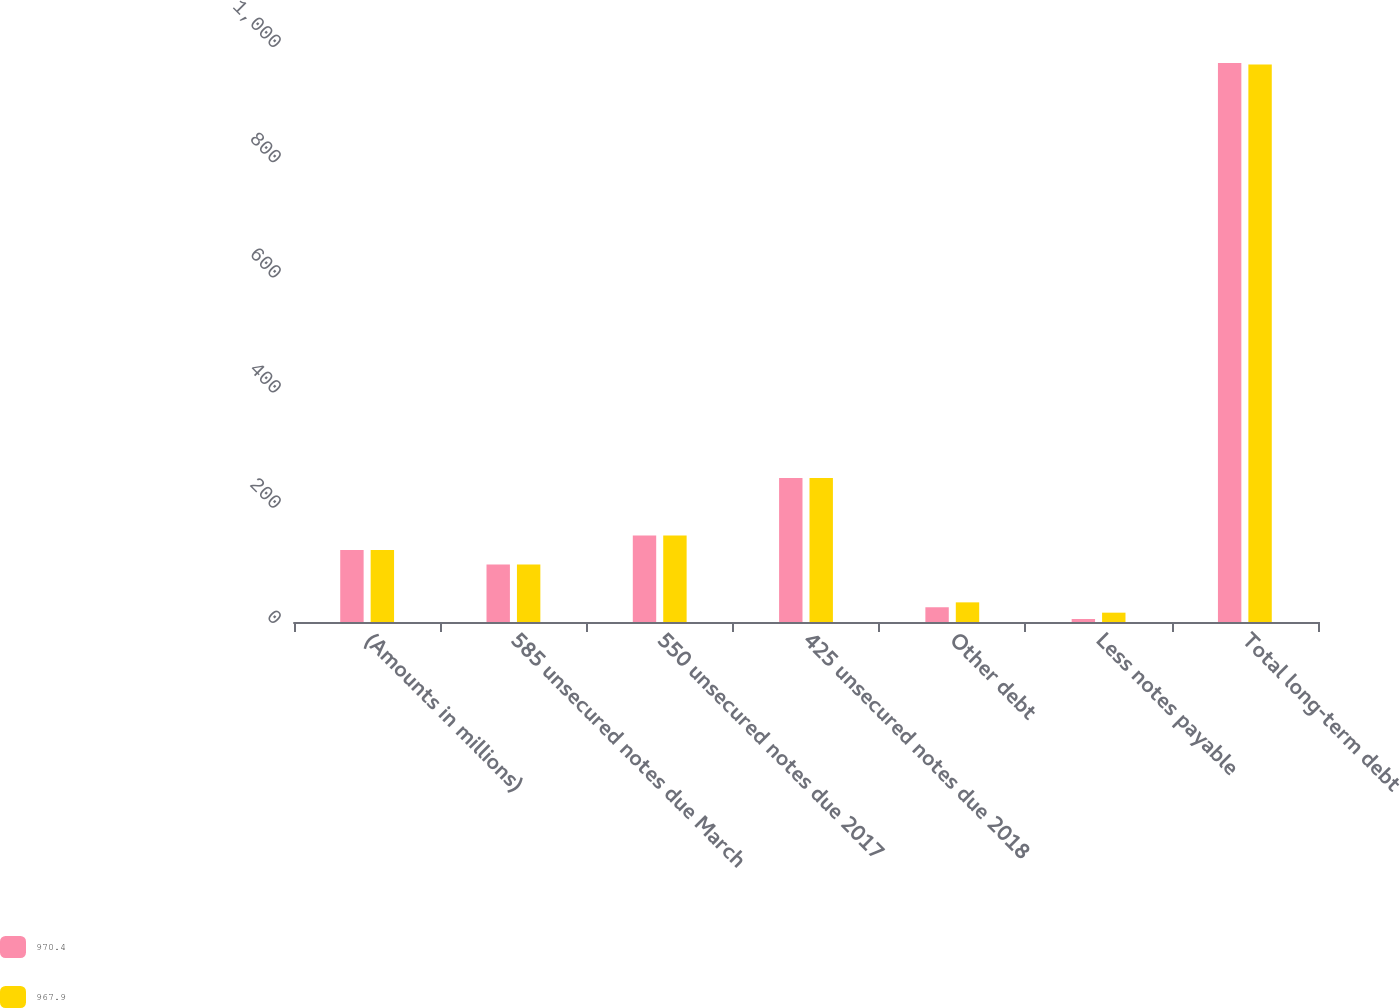Convert chart. <chart><loc_0><loc_0><loc_500><loc_500><stacked_bar_chart><ecel><fcel>(Amounts in millions)<fcel>585 unsecured notes due March<fcel>550 unsecured notes due 2017<fcel>425 unsecured notes due 2018<fcel>Other debt<fcel>Less notes payable<fcel>Total long-term debt<nl><fcel>970.4<fcel>125<fcel>100<fcel>150<fcel>250<fcel>25.6<fcel>5.2<fcel>970.4<nl><fcel>967.9<fcel>125<fcel>100<fcel>150<fcel>250<fcel>34.1<fcel>16.2<fcel>967.9<nl></chart> 